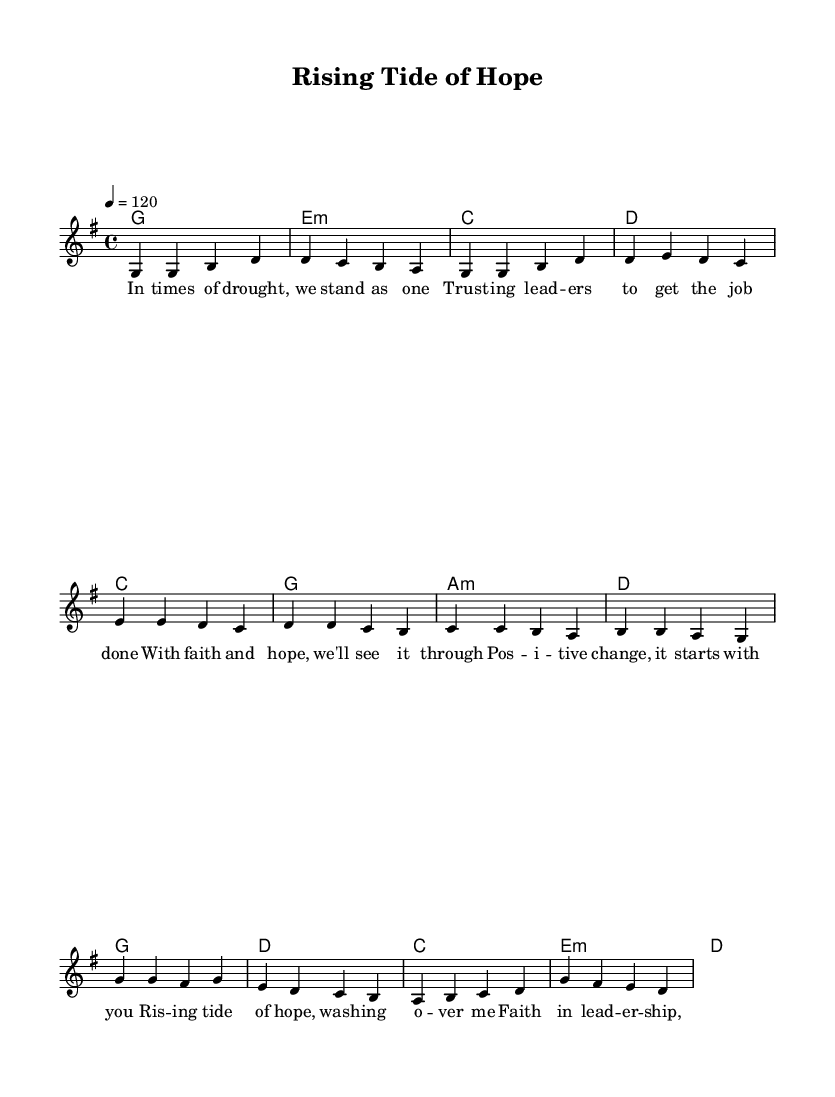What is the key signature of this music? The key signature shown in the music indicates two sharps, which correspond to the notes F# and C#. This means it is in G major.
Answer: G major What is the time signature of this music? The time signature appears at the beginning of the music, showing a "4/4" which means there are four beats in a measure, and the quarter note gets one beat.
Answer: 4/4 What is the tempo of this music? The tempo marking indicates "4 = 120", which signifies that there are 120 beats per minute in this piece.
Answer: 120 How many measures are in the verse section? By counting the groupings of vertical lines, we see there are four measures in the verse section of the music.
Answer: 4 Which chord follows the first melody note in the pre-chorus? In the pre-chorus, the first melody note "e" corresponds to an "e" chord, as indicated in the chord notation beneath the melody.
Answer: E minor What theme is conveyed in the lyrics of this piece? The lyrics speak about unity during difficult times, trust in leadership, and hope for positive change, emphasizing faith as the foundation.
Answer: Faith and hope What is the final chord in the score? The last chord displayed in the musical score at the end of the piece is an "e minor" chord, indicating a resolution in the music.
Answer: E minor 